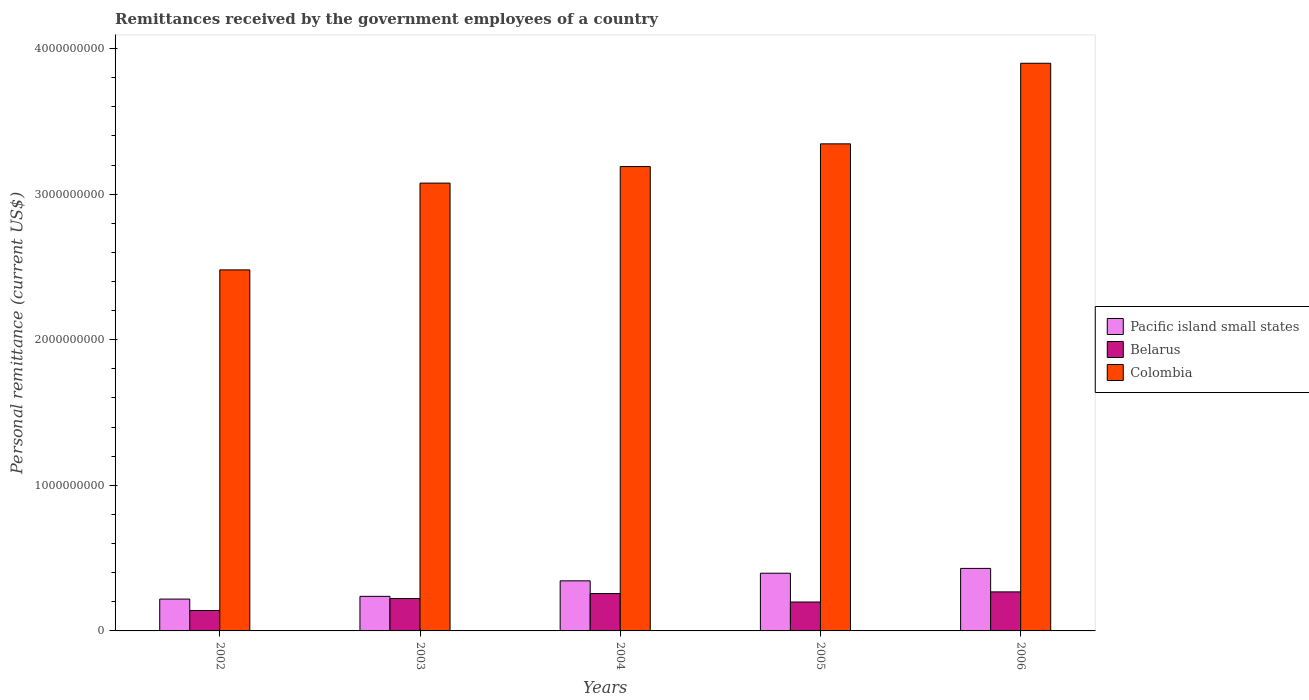How many groups of bars are there?
Keep it short and to the point. 5. Are the number of bars on each tick of the X-axis equal?
Keep it short and to the point. Yes. How many bars are there on the 3rd tick from the left?
Ensure brevity in your answer.  3. What is the label of the 1st group of bars from the left?
Your answer should be very brief. 2002. In how many cases, is the number of bars for a given year not equal to the number of legend labels?
Your answer should be very brief. 0. What is the remittances received by the government employees in Belarus in 2005?
Keep it short and to the point. 1.99e+08. Across all years, what is the maximum remittances received by the government employees in Colombia?
Provide a succinct answer. 3.90e+09. Across all years, what is the minimum remittances received by the government employees in Colombia?
Offer a terse response. 2.48e+09. In which year was the remittances received by the government employees in Belarus maximum?
Keep it short and to the point. 2006. In which year was the remittances received by the government employees in Belarus minimum?
Your response must be concise. 2002. What is the total remittances received by the government employees in Pacific island small states in the graph?
Ensure brevity in your answer.  1.63e+09. What is the difference between the remittances received by the government employees in Pacific island small states in 2005 and that in 2006?
Keep it short and to the point. -3.31e+07. What is the difference between the remittances received by the government employees in Pacific island small states in 2002 and the remittances received by the government employees in Colombia in 2004?
Ensure brevity in your answer.  -2.97e+09. What is the average remittances received by the government employees in Pacific island small states per year?
Provide a succinct answer. 3.25e+08. In the year 2006, what is the difference between the remittances received by the government employees in Colombia and remittances received by the government employees in Belarus?
Provide a succinct answer. 3.63e+09. In how many years, is the remittances received by the government employees in Belarus greater than 1600000000 US$?
Your answer should be compact. 0. What is the ratio of the remittances received by the government employees in Pacific island small states in 2004 to that in 2006?
Offer a very short reply. 0.8. Is the difference between the remittances received by the government employees in Colombia in 2003 and 2004 greater than the difference between the remittances received by the government employees in Belarus in 2003 and 2004?
Make the answer very short. No. What is the difference between the highest and the second highest remittances received by the government employees in Belarus?
Your answer should be compact. 1.15e+07. What is the difference between the highest and the lowest remittances received by the government employees in Belarus?
Offer a very short reply. 1.28e+08. Is the sum of the remittances received by the government employees in Colombia in 2003 and 2004 greater than the maximum remittances received by the government employees in Pacific island small states across all years?
Make the answer very short. Yes. What does the 1st bar from the right in 2005 represents?
Offer a terse response. Colombia. Are all the bars in the graph horizontal?
Give a very brief answer. No. What is the difference between two consecutive major ticks on the Y-axis?
Provide a succinct answer. 1.00e+09. Are the values on the major ticks of Y-axis written in scientific E-notation?
Keep it short and to the point. No. Does the graph contain grids?
Your answer should be very brief. No. What is the title of the graph?
Your answer should be compact. Remittances received by the government employees of a country. Does "Croatia" appear as one of the legend labels in the graph?
Your answer should be compact. No. What is the label or title of the Y-axis?
Ensure brevity in your answer.  Personal remittance (current US$). What is the Personal remittance (current US$) in Pacific island small states in 2002?
Make the answer very short. 2.19e+08. What is the Personal remittance (current US$) in Belarus in 2002?
Give a very brief answer. 1.40e+08. What is the Personal remittance (current US$) of Colombia in 2002?
Keep it short and to the point. 2.48e+09. What is the Personal remittance (current US$) of Pacific island small states in 2003?
Offer a terse response. 2.37e+08. What is the Personal remittance (current US$) of Belarus in 2003?
Ensure brevity in your answer.  2.22e+08. What is the Personal remittance (current US$) of Colombia in 2003?
Give a very brief answer. 3.08e+09. What is the Personal remittance (current US$) in Pacific island small states in 2004?
Ensure brevity in your answer.  3.44e+08. What is the Personal remittance (current US$) in Belarus in 2004?
Your answer should be compact. 2.57e+08. What is the Personal remittance (current US$) in Colombia in 2004?
Offer a terse response. 3.19e+09. What is the Personal remittance (current US$) of Pacific island small states in 2005?
Offer a terse response. 3.96e+08. What is the Personal remittance (current US$) in Belarus in 2005?
Ensure brevity in your answer.  1.99e+08. What is the Personal remittance (current US$) of Colombia in 2005?
Provide a short and direct response. 3.35e+09. What is the Personal remittance (current US$) of Pacific island small states in 2006?
Provide a succinct answer. 4.29e+08. What is the Personal remittance (current US$) in Belarus in 2006?
Your answer should be very brief. 2.68e+08. What is the Personal remittance (current US$) of Colombia in 2006?
Make the answer very short. 3.90e+09. Across all years, what is the maximum Personal remittance (current US$) in Pacific island small states?
Your response must be concise. 4.29e+08. Across all years, what is the maximum Personal remittance (current US$) of Belarus?
Offer a very short reply. 2.68e+08. Across all years, what is the maximum Personal remittance (current US$) of Colombia?
Offer a very short reply. 3.90e+09. Across all years, what is the minimum Personal remittance (current US$) in Pacific island small states?
Your response must be concise. 2.19e+08. Across all years, what is the minimum Personal remittance (current US$) of Belarus?
Provide a short and direct response. 1.40e+08. Across all years, what is the minimum Personal remittance (current US$) of Colombia?
Your answer should be compact. 2.48e+09. What is the total Personal remittance (current US$) in Pacific island small states in the graph?
Ensure brevity in your answer.  1.63e+09. What is the total Personal remittance (current US$) of Belarus in the graph?
Offer a terse response. 1.09e+09. What is the total Personal remittance (current US$) in Colombia in the graph?
Provide a succinct answer. 1.60e+1. What is the difference between the Personal remittance (current US$) of Pacific island small states in 2002 and that in 2003?
Ensure brevity in your answer.  -1.89e+07. What is the difference between the Personal remittance (current US$) of Belarus in 2002 and that in 2003?
Keep it short and to the point. -8.21e+07. What is the difference between the Personal remittance (current US$) in Colombia in 2002 and that in 2003?
Provide a succinct answer. -5.96e+08. What is the difference between the Personal remittance (current US$) in Pacific island small states in 2002 and that in 2004?
Your answer should be compact. -1.25e+08. What is the difference between the Personal remittance (current US$) in Belarus in 2002 and that in 2004?
Provide a short and direct response. -1.16e+08. What is the difference between the Personal remittance (current US$) in Colombia in 2002 and that in 2004?
Your response must be concise. -7.10e+08. What is the difference between the Personal remittance (current US$) in Pacific island small states in 2002 and that in 2005?
Give a very brief answer. -1.78e+08. What is the difference between the Personal remittance (current US$) in Belarus in 2002 and that in 2005?
Offer a terse response. -5.83e+07. What is the difference between the Personal remittance (current US$) of Colombia in 2002 and that in 2005?
Keep it short and to the point. -8.66e+08. What is the difference between the Personal remittance (current US$) in Pacific island small states in 2002 and that in 2006?
Ensure brevity in your answer.  -2.11e+08. What is the difference between the Personal remittance (current US$) in Belarus in 2002 and that in 2006?
Provide a short and direct response. -1.28e+08. What is the difference between the Personal remittance (current US$) of Colombia in 2002 and that in 2006?
Ensure brevity in your answer.  -1.42e+09. What is the difference between the Personal remittance (current US$) in Pacific island small states in 2003 and that in 2004?
Keep it short and to the point. -1.07e+08. What is the difference between the Personal remittance (current US$) in Belarus in 2003 and that in 2004?
Offer a terse response. -3.43e+07. What is the difference between the Personal remittance (current US$) of Colombia in 2003 and that in 2004?
Your answer should be compact. -1.14e+08. What is the difference between the Personal remittance (current US$) of Pacific island small states in 2003 and that in 2005?
Provide a short and direct response. -1.59e+08. What is the difference between the Personal remittance (current US$) in Belarus in 2003 and that in 2005?
Offer a very short reply. 2.38e+07. What is the difference between the Personal remittance (current US$) in Colombia in 2003 and that in 2005?
Offer a terse response. -2.70e+08. What is the difference between the Personal remittance (current US$) in Pacific island small states in 2003 and that in 2006?
Give a very brief answer. -1.92e+08. What is the difference between the Personal remittance (current US$) of Belarus in 2003 and that in 2006?
Offer a very short reply. -4.58e+07. What is the difference between the Personal remittance (current US$) in Colombia in 2003 and that in 2006?
Offer a very short reply. -8.23e+08. What is the difference between the Personal remittance (current US$) in Pacific island small states in 2004 and that in 2005?
Your answer should be very brief. -5.23e+07. What is the difference between the Personal remittance (current US$) of Belarus in 2004 and that in 2005?
Your response must be concise. 5.81e+07. What is the difference between the Personal remittance (current US$) in Colombia in 2004 and that in 2005?
Ensure brevity in your answer.  -1.56e+08. What is the difference between the Personal remittance (current US$) of Pacific island small states in 2004 and that in 2006?
Provide a short and direct response. -8.54e+07. What is the difference between the Personal remittance (current US$) of Belarus in 2004 and that in 2006?
Provide a short and direct response. -1.15e+07. What is the difference between the Personal remittance (current US$) in Colombia in 2004 and that in 2006?
Ensure brevity in your answer.  -7.09e+08. What is the difference between the Personal remittance (current US$) of Pacific island small states in 2005 and that in 2006?
Your answer should be compact. -3.31e+07. What is the difference between the Personal remittance (current US$) of Belarus in 2005 and that in 2006?
Offer a very short reply. -6.96e+07. What is the difference between the Personal remittance (current US$) of Colombia in 2005 and that in 2006?
Offer a terse response. -5.54e+08. What is the difference between the Personal remittance (current US$) in Pacific island small states in 2002 and the Personal remittance (current US$) in Belarus in 2003?
Ensure brevity in your answer.  -3.76e+06. What is the difference between the Personal remittance (current US$) of Pacific island small states in 2002 and the Personal remittance (current US$) of Colombia in 2003?
Give a very brief answer. -2.86e+09. What is the difference between the Personal remittance (current US$) of Belarus in 2002 and the Personal remittance (current US$) of Colombia in 2003?
Make the answer very short. -2.94e+09. What is the difference between the Personal remittance (current US$) in Pacific island small states in 2002 and the Personal remittance (current US$) in Belarus in 2004?
Offer a terse response. -3.81e+07. What is the difference between the Personal remittance (current US$) in Pacific island small states in 2002 and the Personal remittance (current US$) in Colombia in 2004?
Keep it short and to the point. -2.97e+09. What is the difference between the Personal remittance (current US$) in Belarus in 2002 and the Personal remittance (current US$) in Colombia in 2004?
Your answer should be compact. -3.05e+09. What is the difference between the Personal remittance (current US$) in Pacific island small states in 2002 and the Personal remittance (current US$) in Belarus in 2005?
Your response must be concise. 2.00e+07. What is the difference between the Personal remittance (current US$) in Pacific island small states in 2002 and the Personal remittance (current US$) in Colombia in 2005?
Your answer should be very brief. -3.13e+09. What is the difference between the Personal remittance (current US$) in Belarus in 2002 and the Personal remittance (current US$) in Colombia in 2005?
Ensure brevity in your answer.  -3.21e+09. What is the difference between the Personal remittance (current US$) in Pacific island small states in 2002 and the Personal remittance (current US$) in Belarus in 2006?
Provide a short and direct response. -4.96e+07. What is the difference between the Personal remittance (current US$) of Pacific island small states in 2002 and the Personal remittance (current US$) of Colombia in 2006?
Offer a terse response. -3.68e+09. What is the difference between the Personal remittance (current US$) of Belarus in 2002 and the Personal remittance (current US$) of Colombia in 2006?
Your answer should be compact. -3.76e+09. What is the difference between the Personal remittance (current US$) of Pacific island small states in 2003 and the Personal remittance (current US$) of Belarus in 2004?
Provide a succinct answer. -1.92e+07. What is the difference between the Personal remittance (current US$) in Pacific island small states in 2003 and the Personal remittance (current US$) in Colombia in 2004?
Give a very brief answer. -2.95e+09. What is the difference between the Personal remittance (current US$) in Belarus in 2003 and the Personal remittance (current US$) in Colombia in 2004?
Your answer should be very brief. -2.97e+09. What is the difference between the Personal remittance (current US$) of Pacific island small states in 2003 and the Personal remittance (current US$) of Belarus in 2005?
Your response must be concise. 3.89e+07. What is the difference between the Personal remittance (current US$) of Pacific island small states in 2003 and the Personal remittance (current US$) of Colombia in 2005?
Provide a succinct answer. -3.11e+09. What is the difference between the Personal remittance (current US$) in Belarus in 2003 and the Personal remittance (current US$) in Colombia in 2005?
Your answer should be compact. -3.12e+09. What is the difference between the Personal remittance (current US$) of Pacific island small states in 2003 and the Personal remittance (current US$) of Belarus in 2006?
Ensure brevity in your answer.  -3.07e+07. What is the difference between the Personal remittance (current US$) of Pacific island small states in 2003 and the Personal remittance (current US$) of Colombia in 2006?
Provide a succinct answer. -3.66e+09. What is the difference between the Personal remittance (current US$) in Belarus in 2003 and the Personal remittance (current US$) in Colombia in 2006?
Offer a terse response. -3.68e+09. What is the difference between the Personal remittance (current US$) of Pacific island small states in 2004 and the Personal remittance (current US$) of Belarus in 2005?
Ensure brevity in your answer.  1.45e+08. What is the difference between the Personal remittance (current US$) in Pacific island small states in 2004 and the Personal remittance (current US$) in Colombia in 2005?
Offer a very short reply. -3.00e+09. What is the difference between the Personal remittance (current US$) of Belarus in 2004 and the Personal remittance (current US$) of Colombia in 2005?
Your answer should be very brief. -3.09e+09. What is the difference between the Personal remittance (current US$) in Pacific island small states in 2004 and the Personal remittance (current US$) in Belarus in 2006?
Your response must be concise. 7.59e+07. What is the difference between the Personal remittance (current US$) of Pacific island small states in 2004 and the Personal remittance (current US$) of Colombia in 2006?
Offer a terse response. -3.56e+09. What is the difference between the Personal remittance (current US$) in Belarus in 2004 and the Personal remittance (current US$) in Colombia in 2006?
Your response must be concise. -3.64e+09. What is the difference between the Personal remittance (current US$) in Pacific island small states in 2005 and the Personal remittance (current US$) in Belarus in 2006?
Provide a short and direct response. 1.28e+08. What is the difference between the Personal remittance (current US$) of Pacific island small states in 2005 and the Personal remittance (current US$) of Colombia in 2006?
Provide a short and direct response. -3.50e+09. What is the difference between the Personal remittance (current US$) in Belarus in 2005 and the Personal remittance (current US$) in Colombia in 2006?
Give a very brief answer. -3.70e+09. What is the average Personal remittance (current US$) in Pacific island small states per year?
Your response must be concise. 3.25e+08. What is the average Personal remittance (current US$) in Belarus per year?
Your answer should be very brief. 2.17e+08. What is the average Personal remittance (current US$) of Colombia per year?
Ensure brevity in your answer.  3.20e+09. In the year 2002, what is the difference between the Personal remittance (current US$) of Pacific island small states and Personal remittance (current US$) of Belarus?
Provide a succinct answer. 7.83e+07. In the year 2002, what is the difference between the Personal remittance (current US$) in Pacific island small states and Personal remittance (current US$) in Colombia?
Your answer should be very brief. -2.26e+09. In the year 2002, what is the difference between the Personal remittance (current US$) in Belarus and Personal remittance (current US$) in Colombia?
Give a very brief answer. -2.34e+09. In the year 2003, what is the difference between the Personal remittance (current US$) in Pacific island small states and Personal remittance (current US$) in Belarus?
Offer a very short reply. 1.51e+07. In the year 2003, what is the difference between the Personal remittance (current US$) of Pacific island small states and Personal remittance (current US$) of Colombia?
Your answer should be very brief. -2.84e+09. In the year 2003, what is the difference between the Personal remittance (current US$) of Belarus and Personal remittance (current US$) of Colombia?
Make the answer very short. -2.85e+09. In the year 2004, what is the difference between the Personal remittance (current US$) in Pacific island small states and Personal remittance (current US$) in Belarus?
Ensure brevity in your answer.  8.74e+07. In the year 2004, what is the difference between the Personal remittance (current US$) in Pacific island small states and Personal remittance (current US$) in Colombia?
Offer a very short reply. -2.85e+09. In the year 2004, what is the difference between the Personal remittance (current US$) in Belarus and Personal remittance (current US$) in Colombia?
Keep it short and to the point. -2.93e+09. In the year 2005, what is the difference between the Personal remittance (current US$) of Pacific island small states and Personal remittance (current US$) of Belarus?
Your answer should be compact. 1.98e+08. In the year 2005, what is the difference between the Personal remittance (current US$) in Pacific island small states and Personal remittance (current US$) in Colombia?
Offer a terse response. -2.95e+09. In the year 2005, what is the difference between the Personal remittance (current US$) of Belarus and Personal remittance (current US$) of Colombia?
Give a very brief answer. -3.15e+09. In the year 2006, what is the difference between the Personal remittance (current US$) of Pacific island small states and Personal remittance (current US$) of Belarus?
Provide a succinct answer. 1.61e+08. In the year 2006, what is the difference between the Personal remittance (current US$) in Pacific island small states and Personal remittance (current US$) in Colombia?
Ensure brevity in your answer.  -3.47e+09. In the year 2006, what is the difference between the Personal remittance (current US$) of Belarus and Personal remittance (current US$) of Colombia?
Make the answer very short. -3.63e+09. What is the ratio of the Personal remittance (current US$) of Pacific island small states in 2002 to that in 2003?
Offer a very short reply. 0.92. What is the ratio of the Personal remittance (current US$) of Belarus in 2002 to that in 2003?
Give a very brief answer. 0.63. What is the ratio of the Personal remittance (current US$) of Colombia in 2002 to that in 2003?
Give a very brief answer. 0.81. What is the ratio of the Personal remittance (current US$) in Pacific island small states in 2002 to that in 2004?
Keep it short and to the point. 0.64. What is the ratio of the Personal remittance (current US$) of Belarus in 2002 to that in 2004?
Offer a very short reply. 0.55. What is the ratio of the Personal remittance (current US$) of Colombia in 2002 to that in 2004?
Offer a terse response. 0.78. What is the ratio of the Personal remittance (current US$) in Pacific island small states in 2002 to that in 2005?
Keep it short and to the point. 0.55. What is the ratio of the Personal remittance (current US$) of Belarus in 2002 to that in 2005?
Make the answer very short. 0.71. What is the ratio of the Personal remittance (current US$) of Colombia in 2002 to that in 2005?
Provide a short and direct response. 0.74. What is the ratio of the Personal remittance (current US$) in Pacific island small states in 2002 to that in 2006?
Your answer should be very brief. 0.51. What is the ratio of the Personal remittance (current US$) in Belarus in 2002 to that in 2006?
Your answer should be very brief. 0.52. What is the ratio of the Personal remittance (current US$) in Colombia in 2002 to that in 2006?
Provide a succinct answer. 0.64. What is the ratio of the Personal remittance (current US$) in Pacific island small states in 2003 to that in 2004?
Your response must be concise. 0.69. What is the ratio of the Personal remittance (current US$) in Belarus in 2003 to that in 2004?
Your answer should be compact. 0.87. What is the ratio of the Personal remittance (current US$) in Colombia in 2003 to that in 2004?
Your answer should be compact. 0.96. What is the ratio of the Personal remittance (current US$) of Pacific island small states in 2003 to that in 2005?
Keep it short and to the point. 0.6. What is the ratio of the Personal remittance (current US$) of Belarus in 2003 to that in 2005?
Your response must be concise. 1.12. What is the ratio of the Personal remittance (current US$) in Colombia in 2003 to that in 2005?
Ensure brevity in your answer.  0.92. What is the ratio of the Personal remittance (current US$) of Pacific island small states in 2003 to that in 2006?
Make the answer very short. 0.55. What is the ratio of the Personal remittance (current US$) in Belarus in 2003 to that in 2006?
Provide a short and direct response. 0.83. What is the ratio of the Personal remittance (current US$) of Colombia in 2003 to that in 2006?
Ensure brevity in your answer.  0.79. What is the ratio of the Personal remittance (current US$) of Pacific island small states in 2004 to that in 2005?
Ensure brevity in your answer.  0.87. What is the ratio of the Personal remittance (current US$) of Belarus in 2004 to that in 2005?
Keep it short and to the point. 1.29. What is the ratio of the Personal remittance (current US$) of Colombia in 2004 to that in 2005?
Your answer should be compact. 0.95. What is the ratio of the Personal remittance (current US$) in Pacific island small states in 2004 to that in 2006?
Give a very brief answer. 0.8. What is the ratio of the Personal remittance (current US$) in Belarus in 2004 to that in 2006?
Offer a terse response. 0.96. What is the ratio of the Personal remittance (current US$) in Colombia in 2004 to that in 2006?
Ensure brevity in your answer.  0.82. What is the ratio of the Personal remittance (current US$) in Pacific island small states in 2005 to that in 2006?
Provide a succinct answer. 0.92. What is the ratio of the Personal remittance (current US$) in Belarus in 2005 to that in 2006?
Provide a short and direct response. 0.74. What is the ratio of the Personal remittance (current US$) in Colombia in 2005 to that in 2006?
Keep it short and to the point. 0.86. What is the difference between the highest and the second highest Personal remittance (current US$) in Pacific island small states?
Offer a terse response. 3.31e+07. What is the difference between the highest and the second highest Personal remittance (current US$) in Belarus?
Your response must be concise. 1.15e+07. What is the difference between the highest and the second highest Personal remittance (current US$) of Colombia?
Your answer should be compact. 5.54e+08. What is the difference between the highest and the lowest Personal remittance (current US$) in Pacific island small states?
Make the answer very short. 2.11e+08. What is the difference between the highest and the lowest Personal remittance (current US$) in Belarus?
Your response must be concise. 1.28e+08. What is the difference between the highest and the lowest Personal remittance (current US$) of Colombia?
Give a very brief answer. 1.42e+09. 